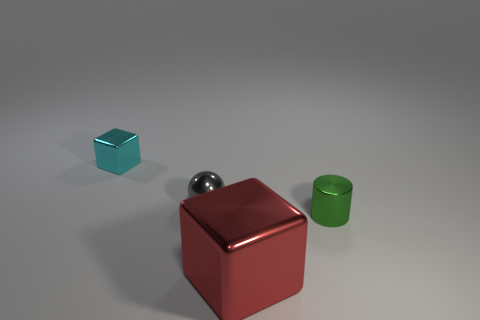Add 1 small things. How many objects exist? 5 Subtract all cylinders. How many objects are left? 3 Subtract all big green shiny spheres. Subtract all red things. How many objects are left? 3 Add 4 metal spheres. How many metal spheres are left? 5 Add 2 large blocks. How many large blocks exist? 3 Subtract 0 brown spheres. How many objects are left? 4 